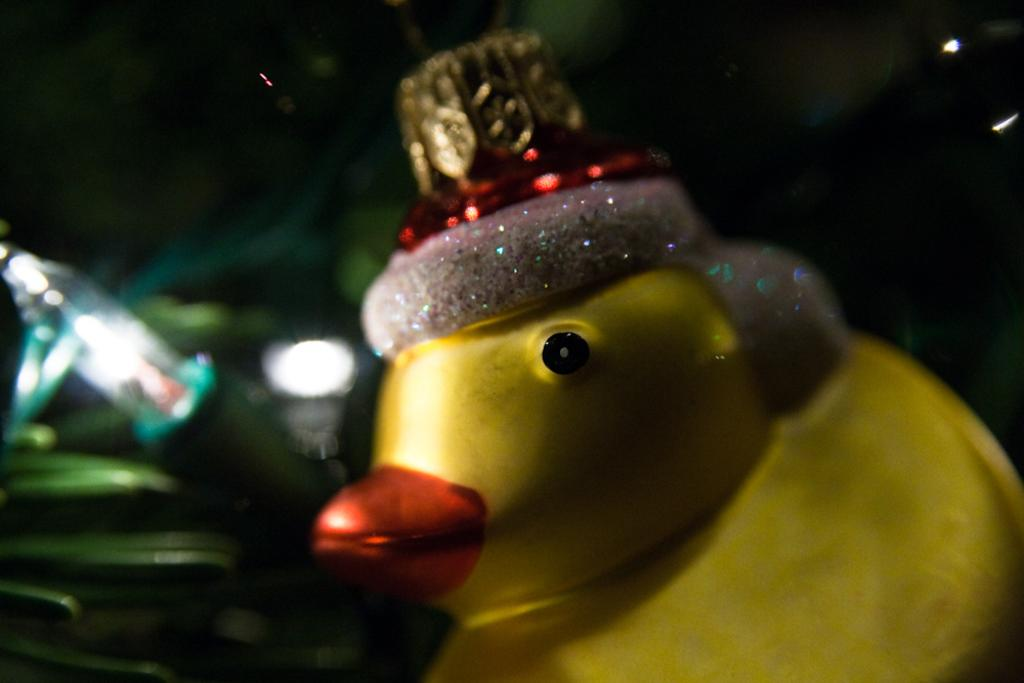What object in the image is typically associated with play? There is a toy in the image, which is typically associated with play. What object in the image provides illumination? There is a light in the image, which provides illumination. What can be said about the background of the image? The background of the image is dark. How many trees can be seen in the image? There are no trees present in the image. What type of design is featured on the toy in the image? The provided facts do not mention any specific design on the toy in the image. Where is the toothbrush located in the image? There is no toothbrush present in the image. 